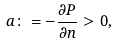<formula> <loc_0><loc_0><loc_500><loc_500>a \colon = - \frac { \partial P } { \partial n } > 0 ,</formula> 